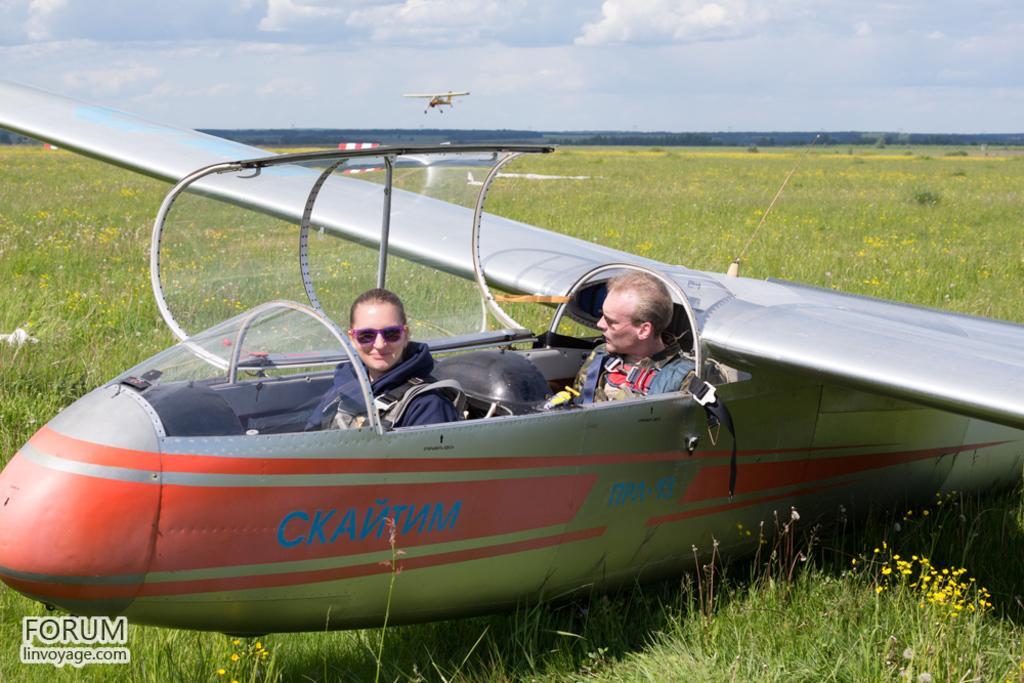Can you describe this image briefly? In this picture, we see the man and the women are riding the airplane. At the bottom, we see the grass and the flowers in yellow color. In the background, we see an airplane is flying in the sky. There are trees in the background. At the top, we see the sky and the clouds. 